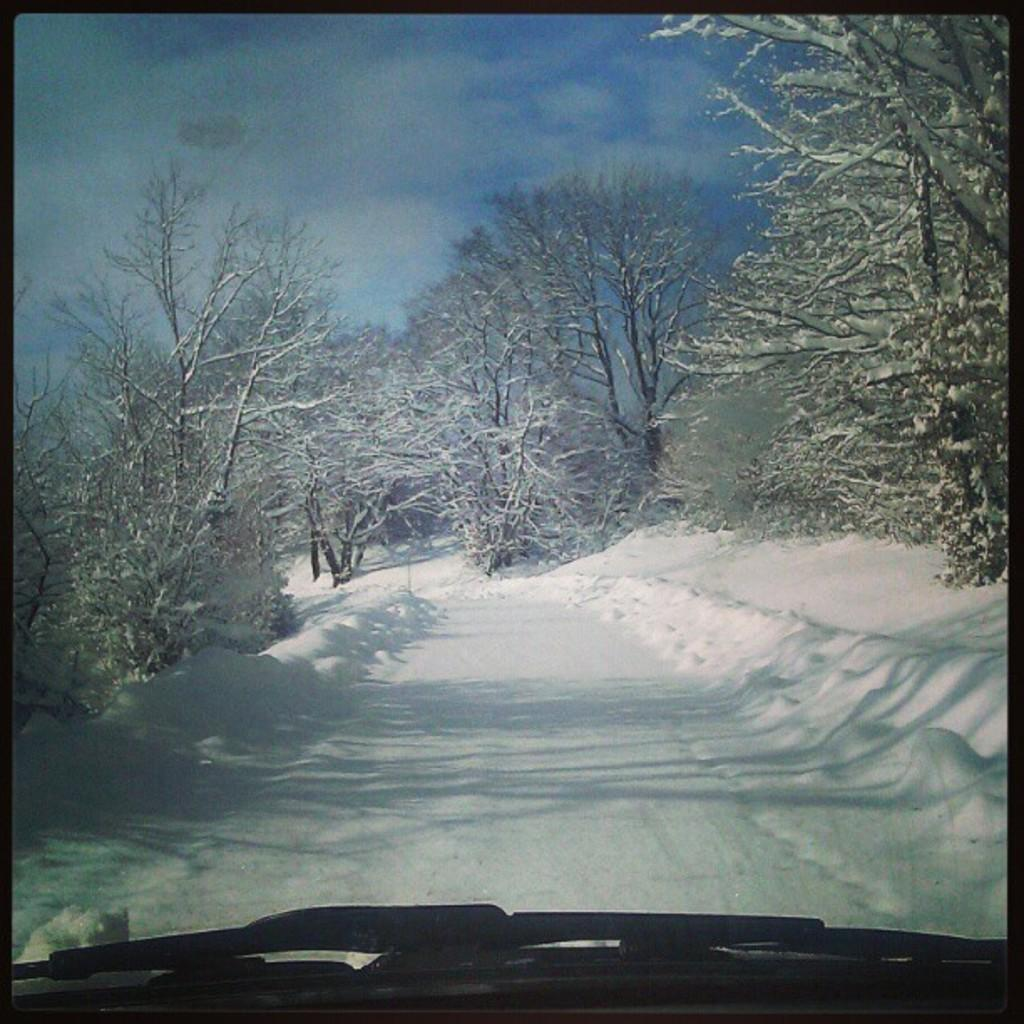What is the main subject of the image? The main subject of the image is the front part of a car. What type of natural environment is visible in the image? There is grass, trees, and the sky visible in the image. Can you describe the time of day when the image was taken? The image was taken during the day. Who is the uncle standing next to the car in the image? There is no uncle present in the image; it only shows the front part of a car and the surrounding environment. 